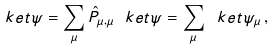<formula> <loc_0><loc_0><loc_500><loc_500>\ k e t { \psi } = \sum _ { \mu } \hat { P } _ { \mu , \mu } \ k e t { \psi } = \sum _ { \mu } \ k e t { \psi _ { \mu } } \, ,</formula> 